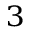Convert formula to latex. <formula><loc_0><loc_0><loc_500><loc_500>^ { 3 }</formula> 